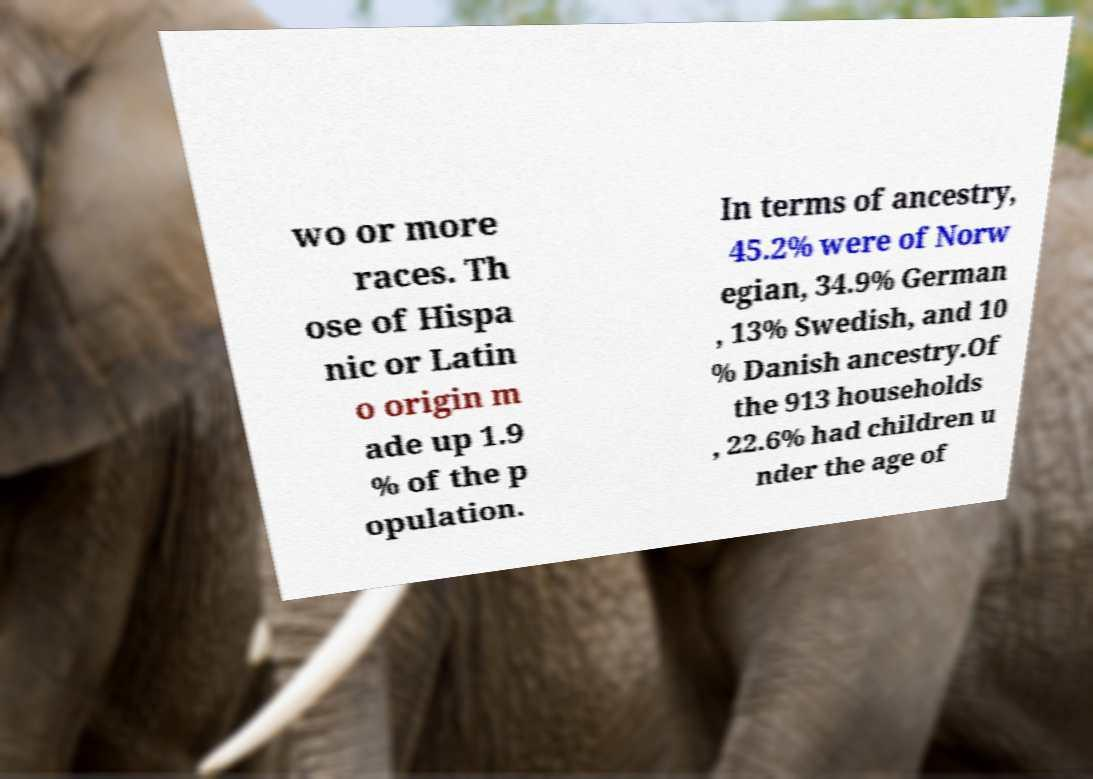Please identify and transcribe the text found in this image. wo or more races. Th ose of Hispa nic or Latin o origin m ade up 1.9 % of the p opulation. In terms of ancestry, 45.2% were of Norw egian, 34.9% German , 13% Swedish, and 10 % Danish ancestry.Of the 913 households , 22.6% had children u nder the age of 